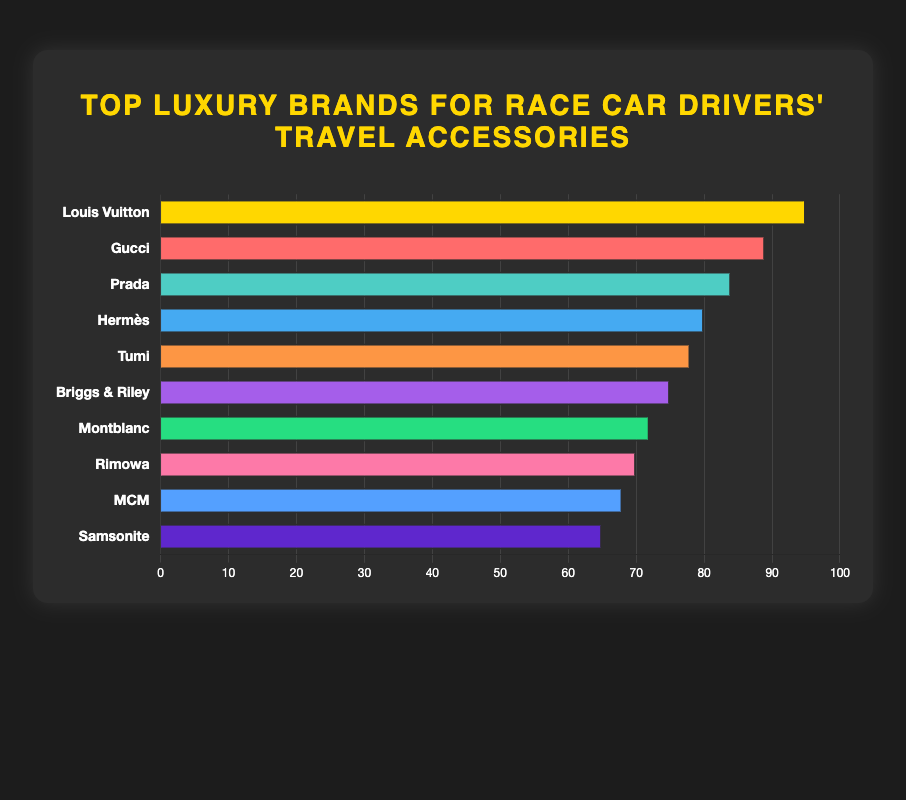Which brand has the highest popularity score? By looking at the bar chart, the longest bar represents the brand with the highest popularity score. The longest bar corresponds to Louis Vuitton.
Answer: Louis Vuitton Which two brands have the closest popularity scores to each other? By comparing the lengths of the bars, we find that Montblanc and Rimowa have scores of 72 and 70, respectively, showing the closest similarity.
Answer: Montblanc and Rimowa What is the total popularity score of the top three brands? Sum the popularity scores of the top three brands: Louis Vuitton (95) + Gucci (89) + Prada (84) = 268.
Answer: 268 Which brand is more popular, MCM or Tumi, and by how much? By comparing the lengths of the bars for MCM (68) and Tumi (78), Tumi is more popular by 10 points.
Answer: Tumi, by 10 points How many brands have a popularity score above 80? Count the bars with scores greater than 80: Louis Vuitton (95), Gucci (89), Prada (84), and Hermès (80). There are four such brands.
Answer: 4 What is the average popularity score of the bottom five brands? Sum the popularity scores of the bottom five brands (Tumi, Briggs & Riley, Montblanc, Rimowa, MCM, Samsonite) and divide by 5: (78 + 75 + 72 + 70 + 68 + 65) / 5 = 356 / 5 = 71.2.
Answer: 71.2 How much higher is Louis Vuitton's popularity score compared to Samsonite? Subtract Samsonite's score (65) from Louis Vuitton's score (95): 95 - 65 = 30.
Answer: 30 Which brand has the least popularity score? The shortest bar represents the brand with the lowest score, which is Samsonite.
Answer: Samsonite What is the combined popularity score of the brands with scores below 70? Sum the popularity scores of Montblanc (72), Rimowa (70), MCM (68), and Samsonite (65): 72 + 70 + 68 + 65 = 275.
Answer: 275 